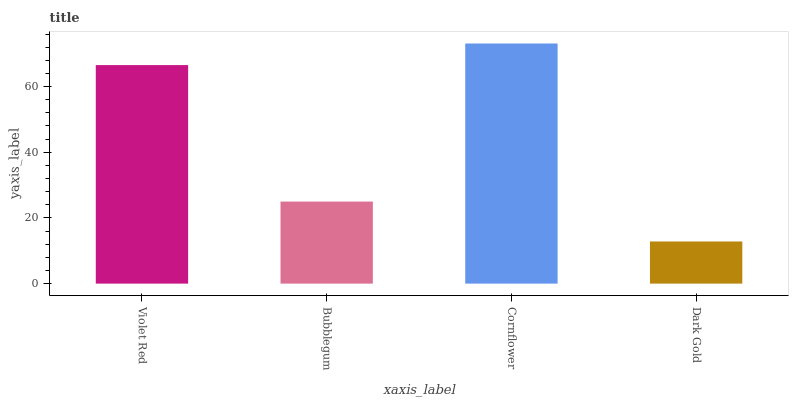Is Dark Gold the minimum?
Answer yes or no. Yes. Is Cornflower the maximum?
Answer yes or no. Yes. Is Bubblegum the minimum?
Answer yes or no. No. Is Bubblegum the maximum?
Answer yes or no. No. Is Violet Red greater than Bubblegum?
Answer yes or no. Yes. Is Bubblegum less than Violet Red?
Answer yes or no. Yes. Is Bubblegum greater than Violet Red?
Answer yes or no. No. Is Violet Red less than Bubblegum?
Answer yes or no. No. Is Violet Red the high median?
Answer yes or no. Yes. Is Bubblegum the low median?
Answer yes or no. Yes. Is Cornflower the high median?
Answer yes or no. No. Is Violet Red the low median?
Answer yes or no. No. 